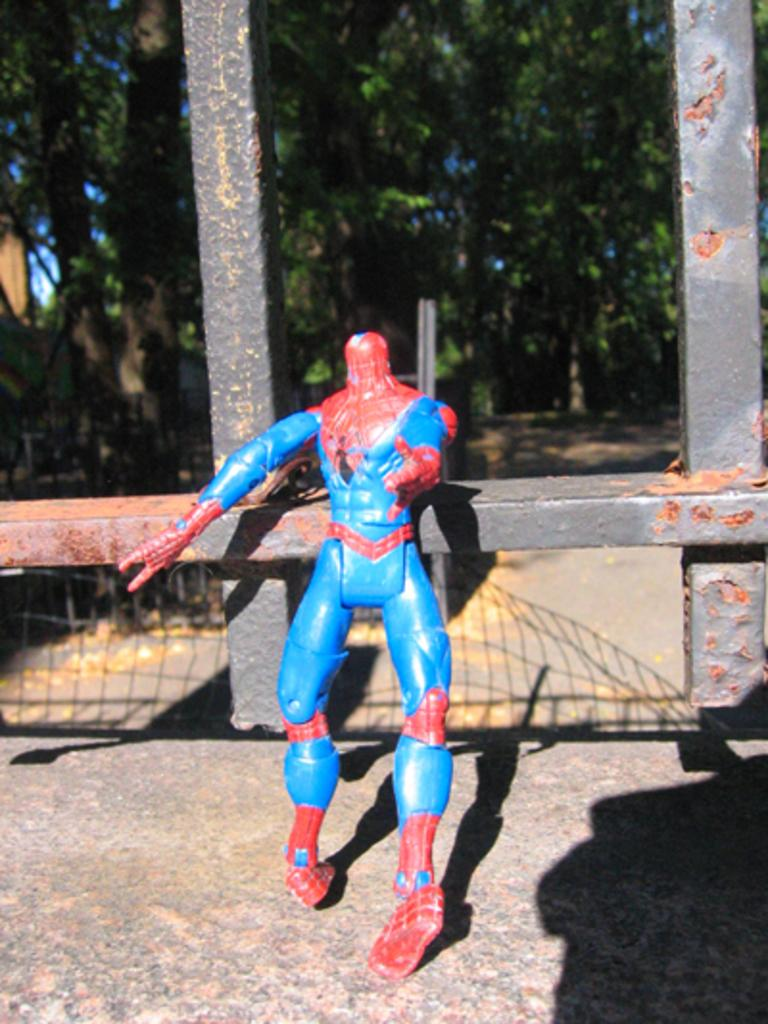What object is present on the road in the image? There is a toy standing on the road in the image. What can be seen in the background of the image? There are metal rods and trees in the background of the image. What type of prison is visible in the background of the image? There is no prison present in the image; it only features a toy on the road and metal rods and trees in the background. 